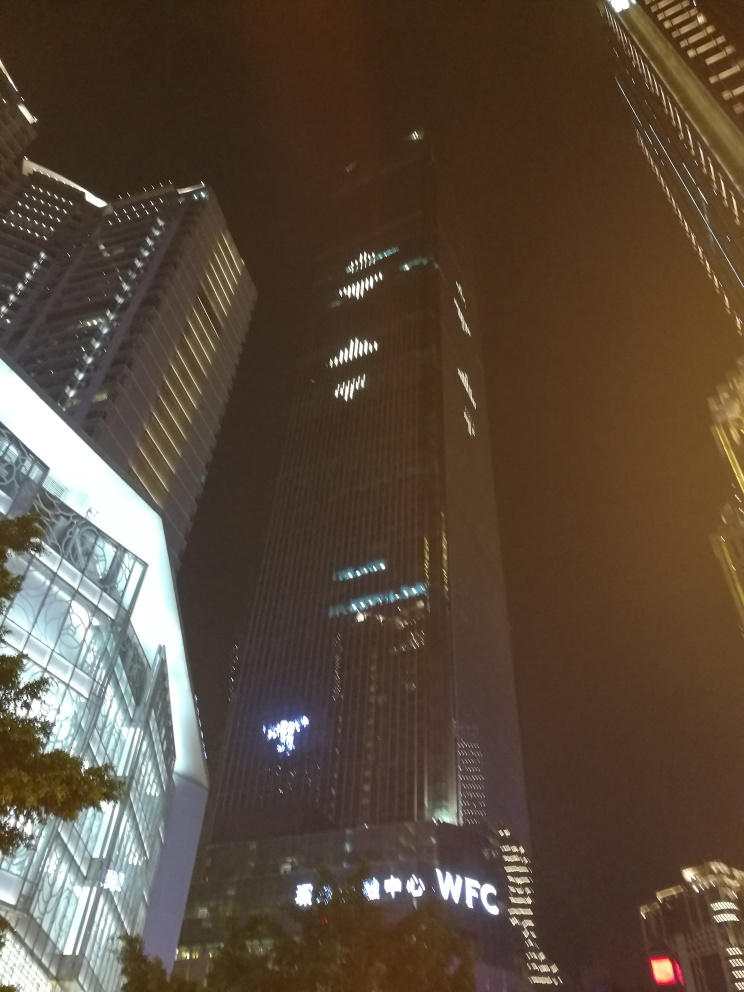Can you tell anything about the weather conditions? The image doesn't provide explicit details about the current weather conditions since it's taken at night and focuses primarily on the buildings. However, the clarity of the lights and the lack of haze or mist suggest that it's likely a clear night with no immediate signs of rain or fog. 